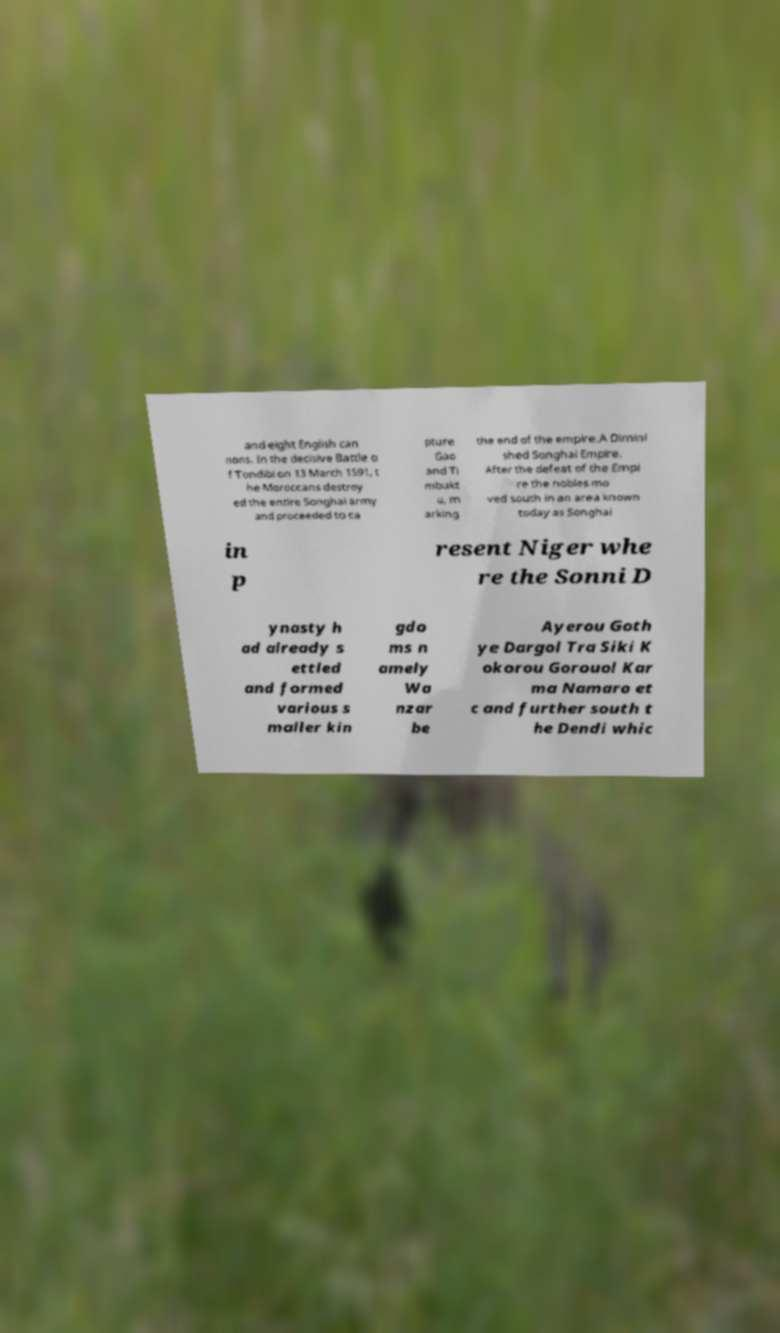Can you accurately transcribe the text from the provided image for me? and eight English can nons. In the decisive Battle o f Tondibi on 13 March 1591, t he Moroccans destroy ed the entire Songhai army and proceeded to ca pture Gao and Ti mbukt u, m arking the end of the empire.A Dimini shed Songhai Empire. After the defeat of the Empi re the nobles mo ved south in an area known today as Songhai in p resent Niger whe re the Sonni D ynasty h ad already s ettled and formed various s maller kin gdo ms n amely Wa nzar be Ayerou Goth ye Dargol Tra Siki K okorou Gorouol Kar ma Namaro et c and further south t he Dendi whic 